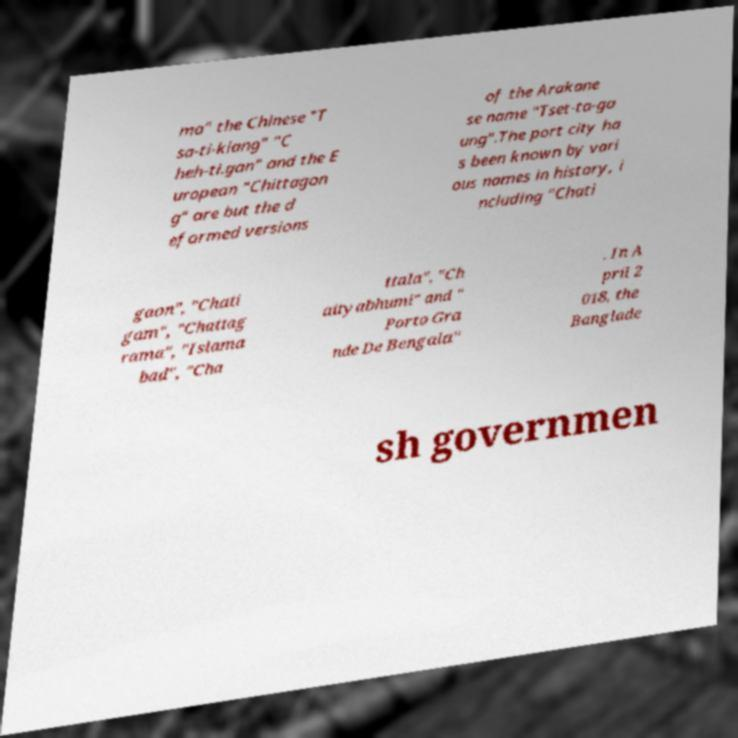Could you extract and type out the text from this image? ma" the Chinese "T sa-ti-kiang" "C heh-ti.gan" and the E uropean "Chittagon g" are but the d eformed versions of the Arakane se name "Tset-ta-ga ung".The port city ha s been known by vari ous names in history, i ncluding "Chati gaon", "Chati gam", "Chattag rama", "Islama bad", "Cha ttala", "Ch aityabhumi" and " Porto Gra nde De Bengala" . In A pril 2 018, the Banglade sh governmen 